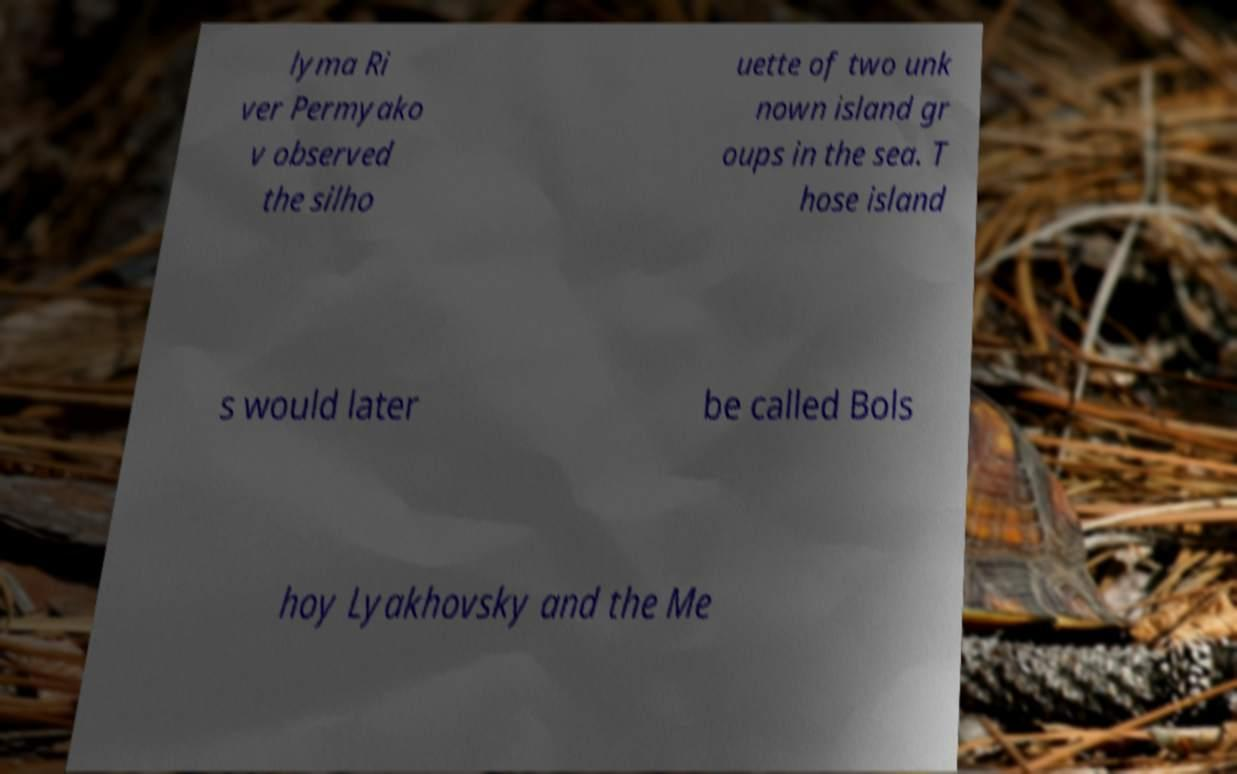What messages or text are displayed in this image? I need them in a readable, typed format. lyma Ri ver Permyako v observed the silho uette of two unk nown island gr oups in the sea. T hose island s would later be called Bols hoy Lyakhovsky and the Me 